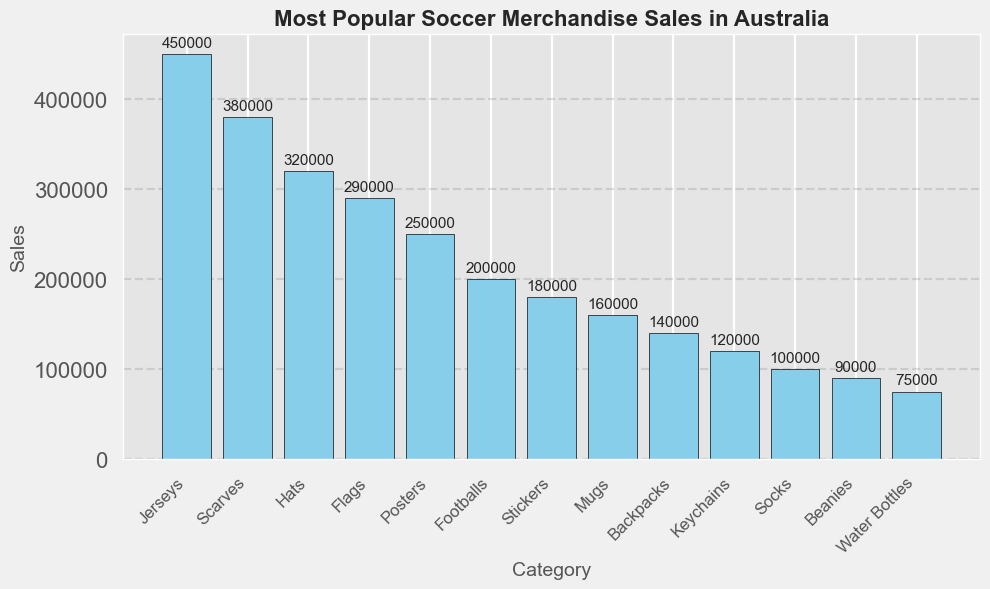Which category has the highest sales? The category with the highest bar in the bar chart has the highest sales. In this case, the "Jerseys" category has the tallest bar, indicating it has the highest sales.
Answer: Jerseys What is the total sales of the top three categories? The top three categories are Jerseys (450,000), Scarves (380,000), and Hats (320,000). Add their sales values: 450,000 + 380,000 + 320,000 = 1,150,000.
Answer: 1,150,000 How much higher are sales of Flags compared to Keychains? The sales of Flags are 290,000 and the sales of Keychains are 120,000. The difference is 290,000 - 120,000 = 170,000.
Answer: 170,000 Which category has the lowest sales? The category with the shortest bar in the bar chart has the lowest sales. In this case, the "Water Bottles" category has the shortest bar, indicating it has the lowest sales.
Answer: Water Bottles How do sales of Scarves compare to sales of Footballs? The sales of Scarves are 380,000 and the sales of Footballs are 200,000. Scarves sales are higher.
Answer: Scarves What are the sales values of the categories with the second and third lowest sales, respectively? The categories with the second and third lowest sales are Beanies (90,000) and Socks (100,000).
Answer: Beanies: 90,000; Socks: 100,000 Calculate the average sales for Hats, Flags, and Posters. The sales are Hats (320,000), Flags (290,000), and Posters (250,000). Average = (320,000 + 290,000 + 250,000) / 3 = 860,000 / 3 ≈ 286,667.
Answer: 286,667 Are sales of Mugs higher or lower than those of Stickers? The sales of Mugs are 160,000 and the sales of Stickers are 180,000. Therefore, the sales of Mugs are lower.
Answer: Lower What's the difference in sales between Jerseys and Socks? The sales of Jerseys are 450,000 and the sales of Socks are 100,000. The difference is 450,000 - 100,000 = 350,000.
Answer: 350,000 What is the combined sales of Beanies and Water Bottles? The sales of Beanies are 90,000 and the sales of Water Bottles are 75,000. Combined sales = 90,000 + 75,000 = 165,000.
Answer: 165,000 